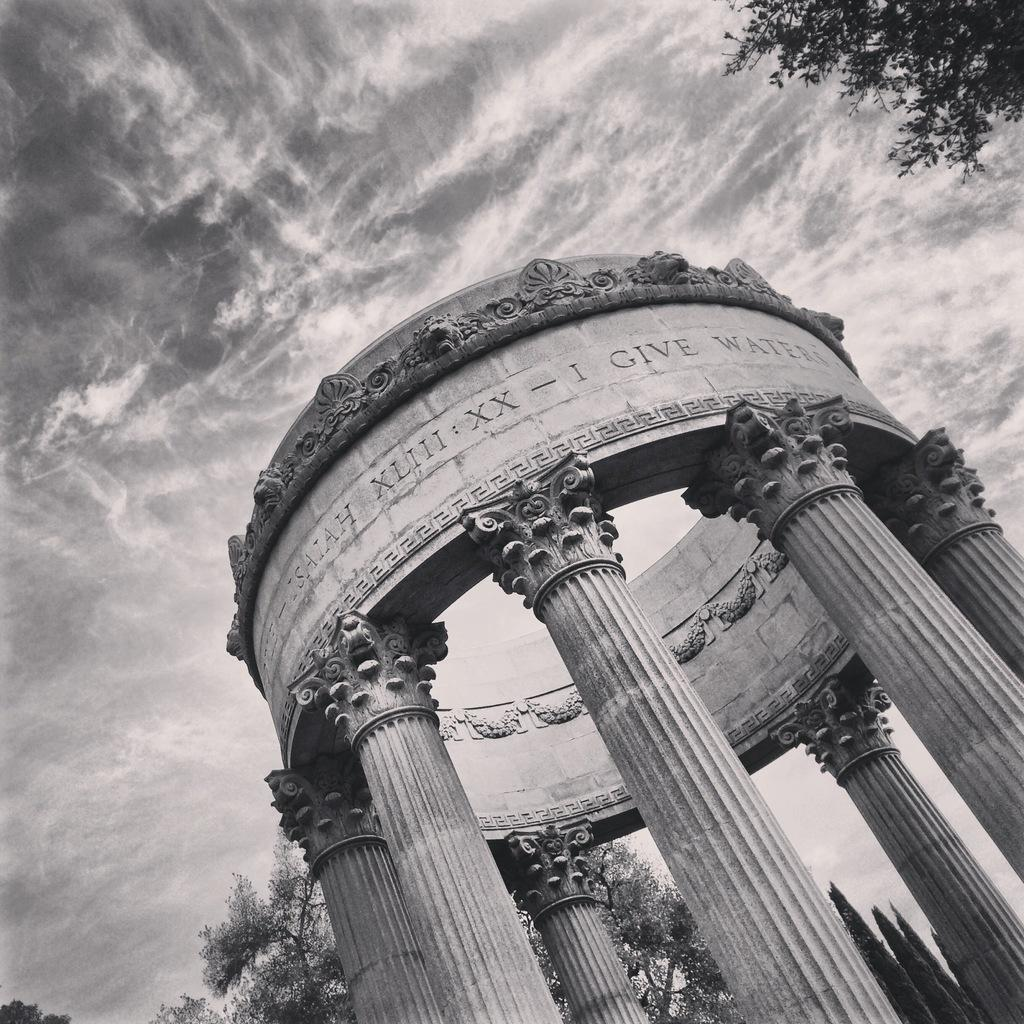What structures are depicted in the image? There are monuments in the image. What type of natural elements can be seen in the background of the image? There are trees in the background of the image. What is visible at the top of the image? The sky is visible at the top of the image. What can be observed in the sky? Clouds are present in the sky. Where is the cow located in the image? There is no cow present in the image. What type of weapon is attached to the quiver in the image? There is no quiver present in the image. 